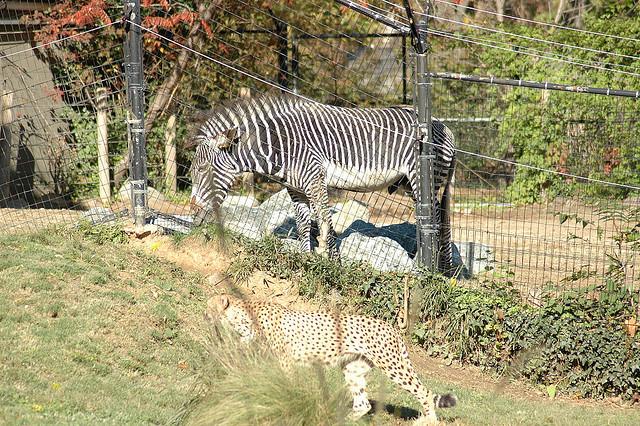Why might a zookeeper want to keep these animals apart?
Write a very short answer. Predator. What animal is the fastest?
Short answer required. Cheetah. How many animals are in the image?
Keep it brief. 2. What is the gender of the zebra?
Write a very short answer. Male. How many zebras are in the picture?
Quick response, please. 1. 